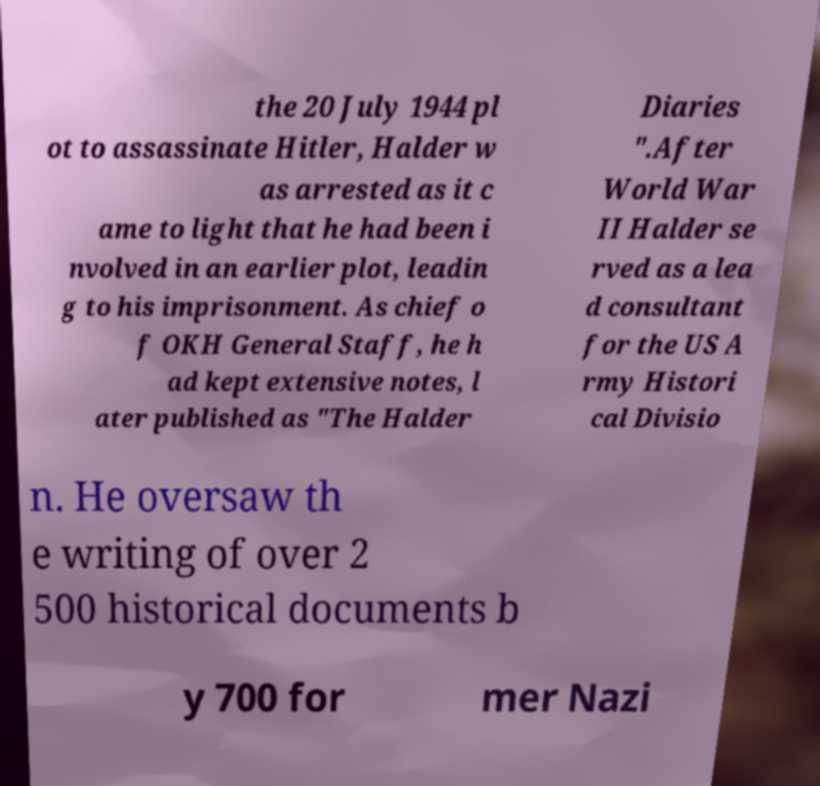Could you extract and type out the text from this image? the 20 July 1944 pl ot to assassinate Hitler, Halder w as arrested as it c ame to light that he had been i nvolved in an earlier plot, leadin g to his imprisonment. As chief o f OKH General Staff, he h ad kept extensive notes, l ater published as "The Halder Diaries ".After World War II Halder se rved as a lea d consultant for the US A rmy Histori cal Divisio n. He oversaw th e writing of over 2 500 historical documents b y 700 for mer Nazi 